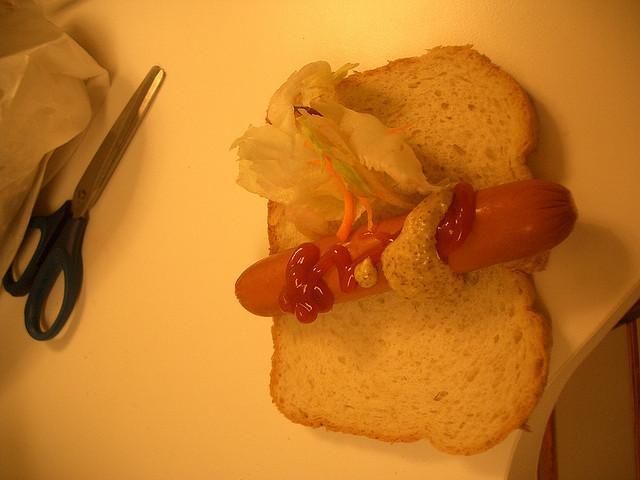How many different vegetables were used to create the red sauce on the hot dog?

Choices:
A) one
B) three
C) four
D) two one 